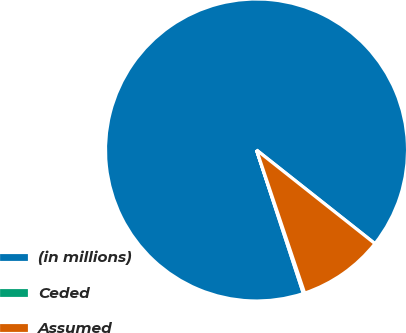Convert chart. <chart><loc_0><loc_0><loc_500><loc_500><pie_chart><fcel>(in millions)<fcel>Ceded<fcel>Assumed<nl><fcel>90.68%<fcel>0.14%<fcel>9.19%<nl></chart> 